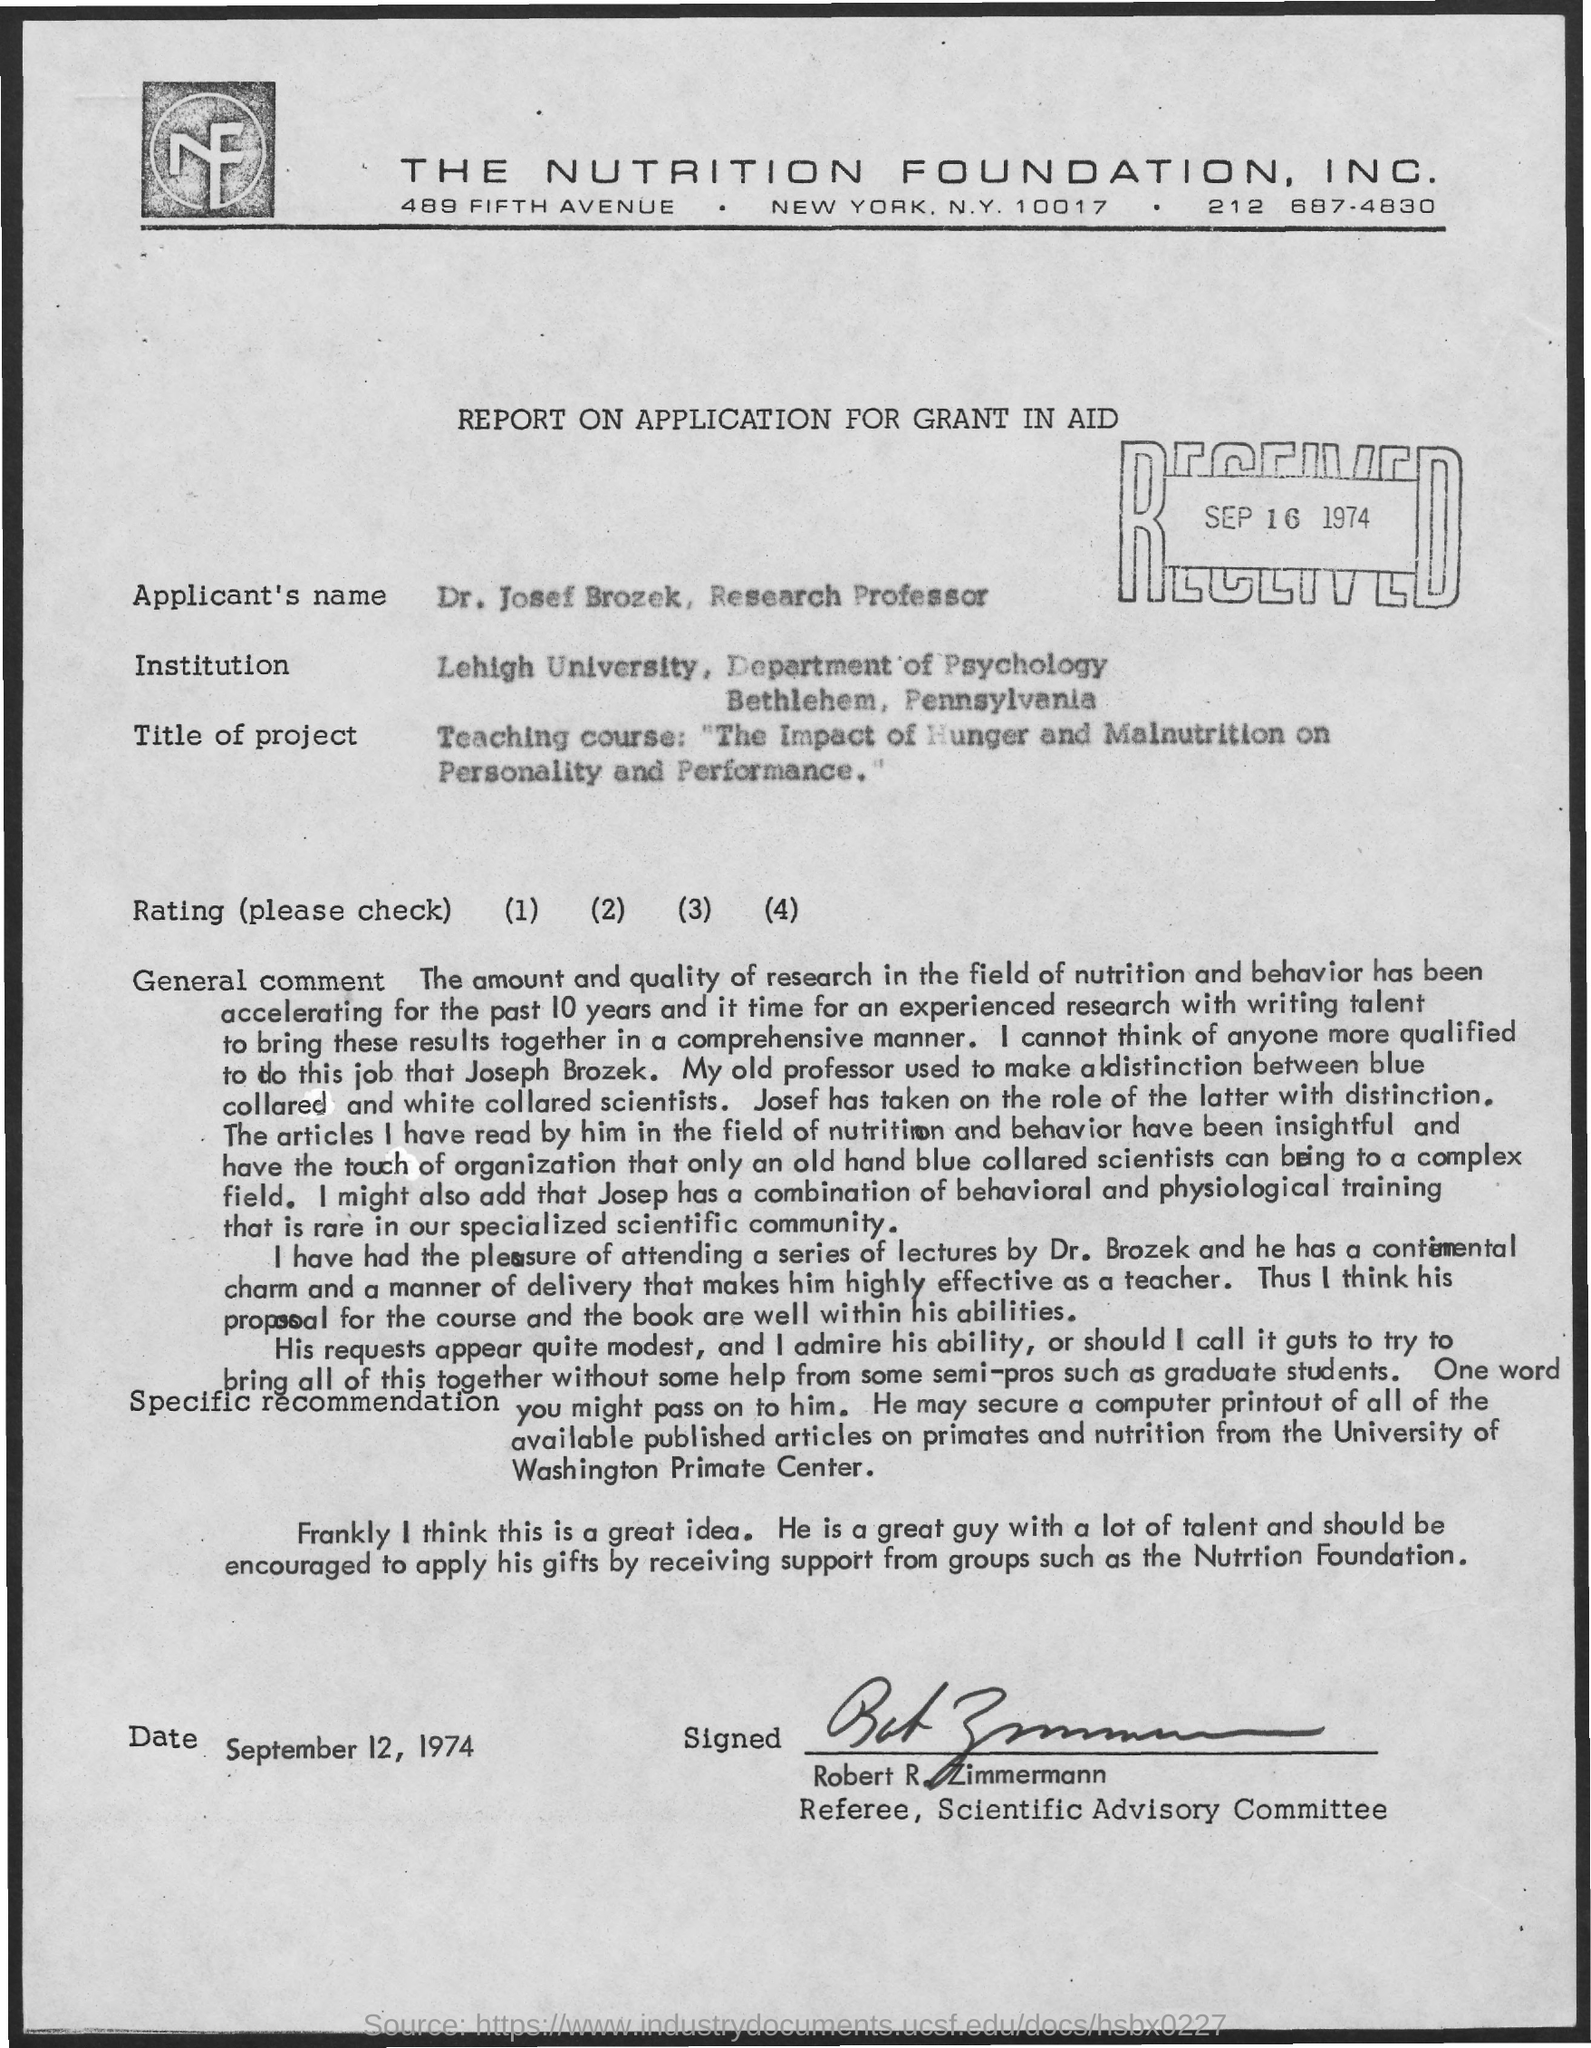What is the contact of the nutrition foundation, inc.?
Keep it short and to the point. 212 687-4830. What is the report on?
Your answer should be very brief. Application for grant in aid. What is applicant's name ?
Give a very brief answer. Dr. Josef Brozek, Research Professor. What is the date at bottom of the page?
Your answer should be very brief. September 12, 1974. 